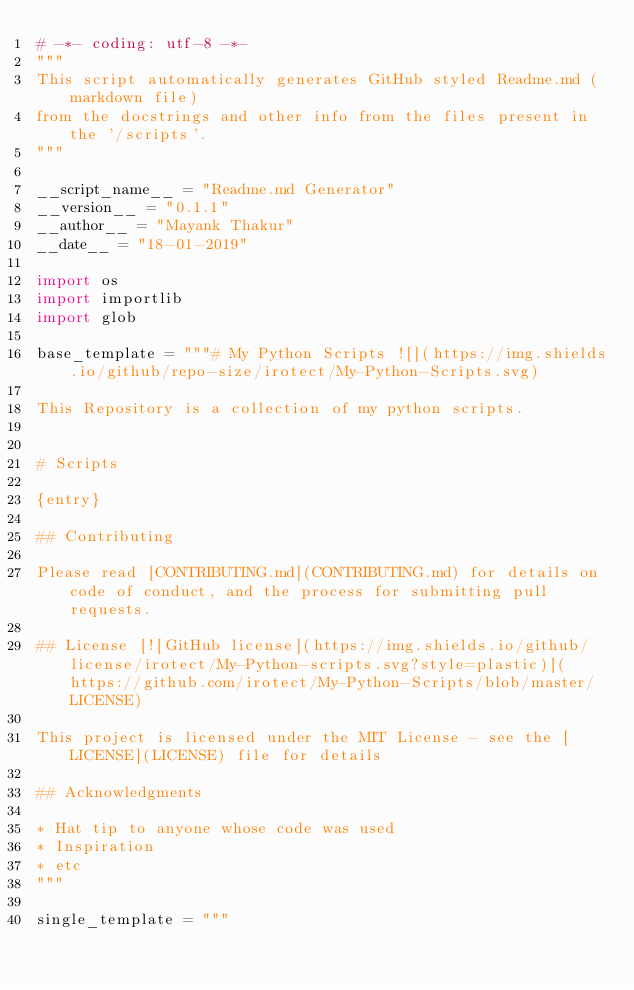<code> <loc_0><loc_0><loc_500><loc_500><_Python_># -*- coding: utf-8 -*-
"""
This script automatically generates GitHub styled Readme.md (markdown file)
from the docstrings and other info from the files present in the '/scripts'.
"""

__script_name__ = "Readme.md Generator"
__version__ = "0.1.1"
__author__ = "Mayank Thakur"
__date__ = "18-01-2019"

import os
import importlib
import glob

base_template = """# My Python Scripts ![](https://img.shields.io/github/repo-size/irotect/My-Python-Scripts.svg)

This Repository is a collection of my python scripts.


# Scripts

{entry}

## Contributing

Please read [CONTRIBUTING.md](CONTRIBUTING.md) for details on code of conduct, and the process for submitting pull requests.

## License [![GitHub license](https://img.shields.io/github/license/irotect/My-Python-scripts.svg?style=plastic)](https://github.com/irotect/My-Python-Scripts/blob/master/LICENSE)

This project is licensed under the MIT License - see the [LICENSE](LICENSE) file for details

## Acknowledgments

* Hat tip to anyone whose code was used
* Inspiration
* etc
"""

single_template = """</code> 